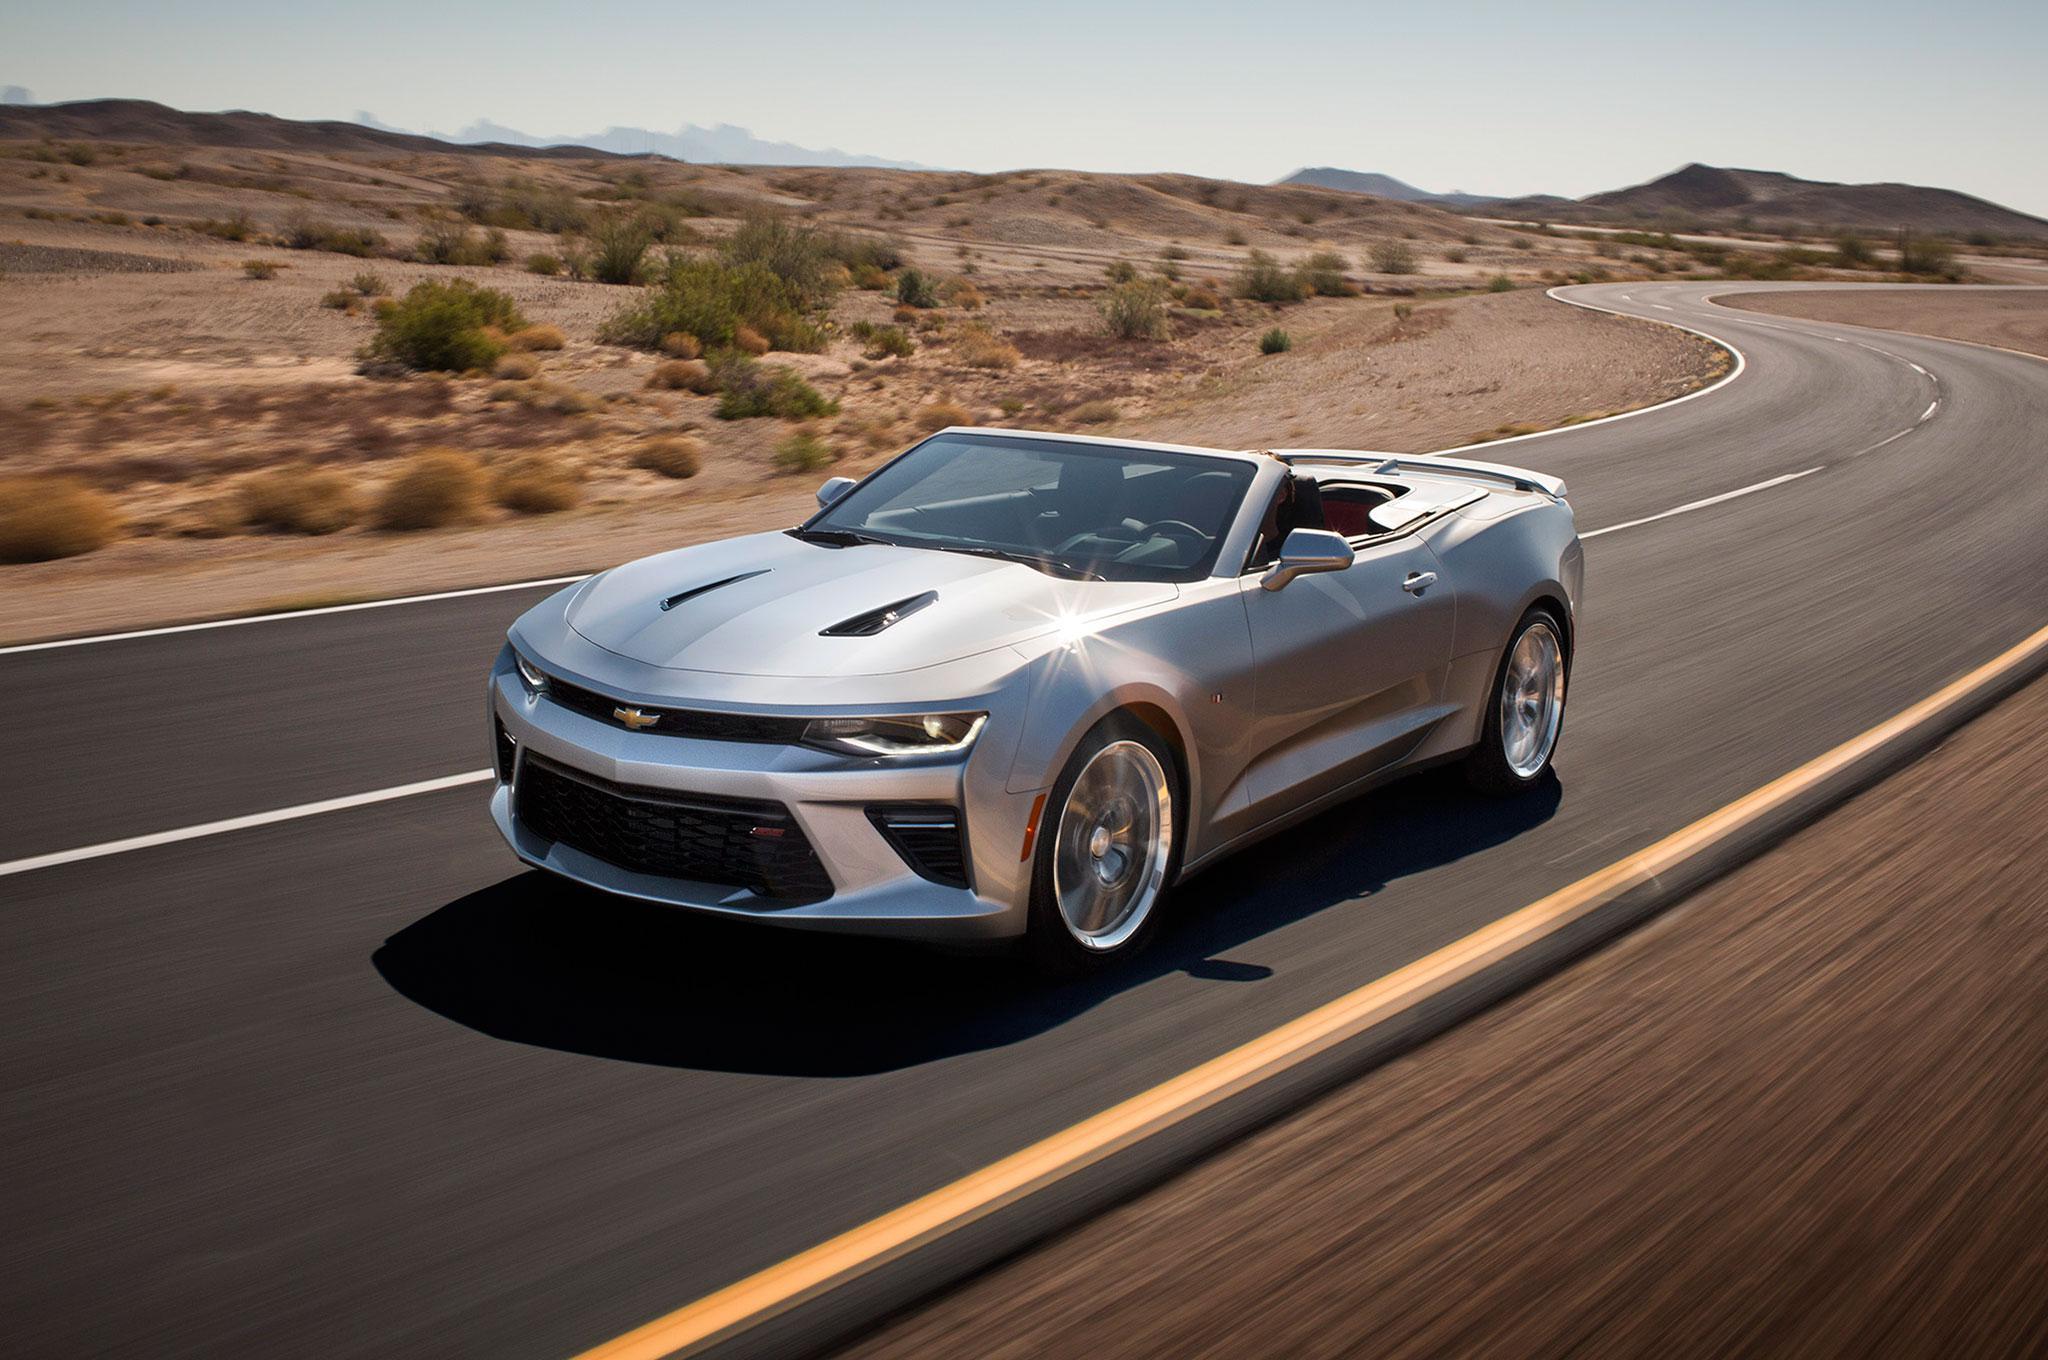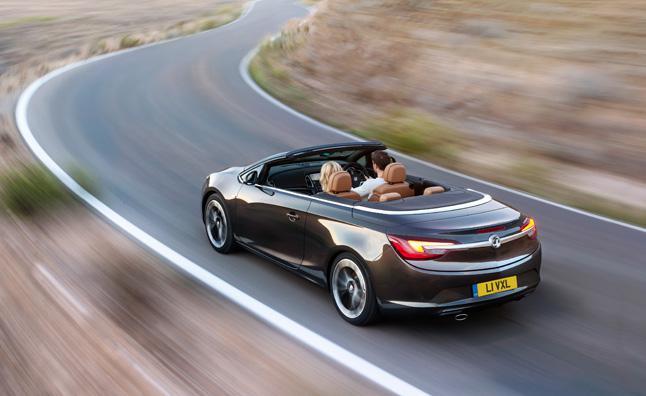The first image is the image on the left, the second image is the image on the right. For the images shown, is this caption "Two convertibles of different makes and colors, with tops down, are being driven on open roads with no other visible traffic." true? Answer yes or no. Yes. The first image is the image on the left, the second image is the image on the right. For the images shown, is this caption "All cars are photographed with a blurry background as if they are moving." true? Answer yes or no. Yes. 